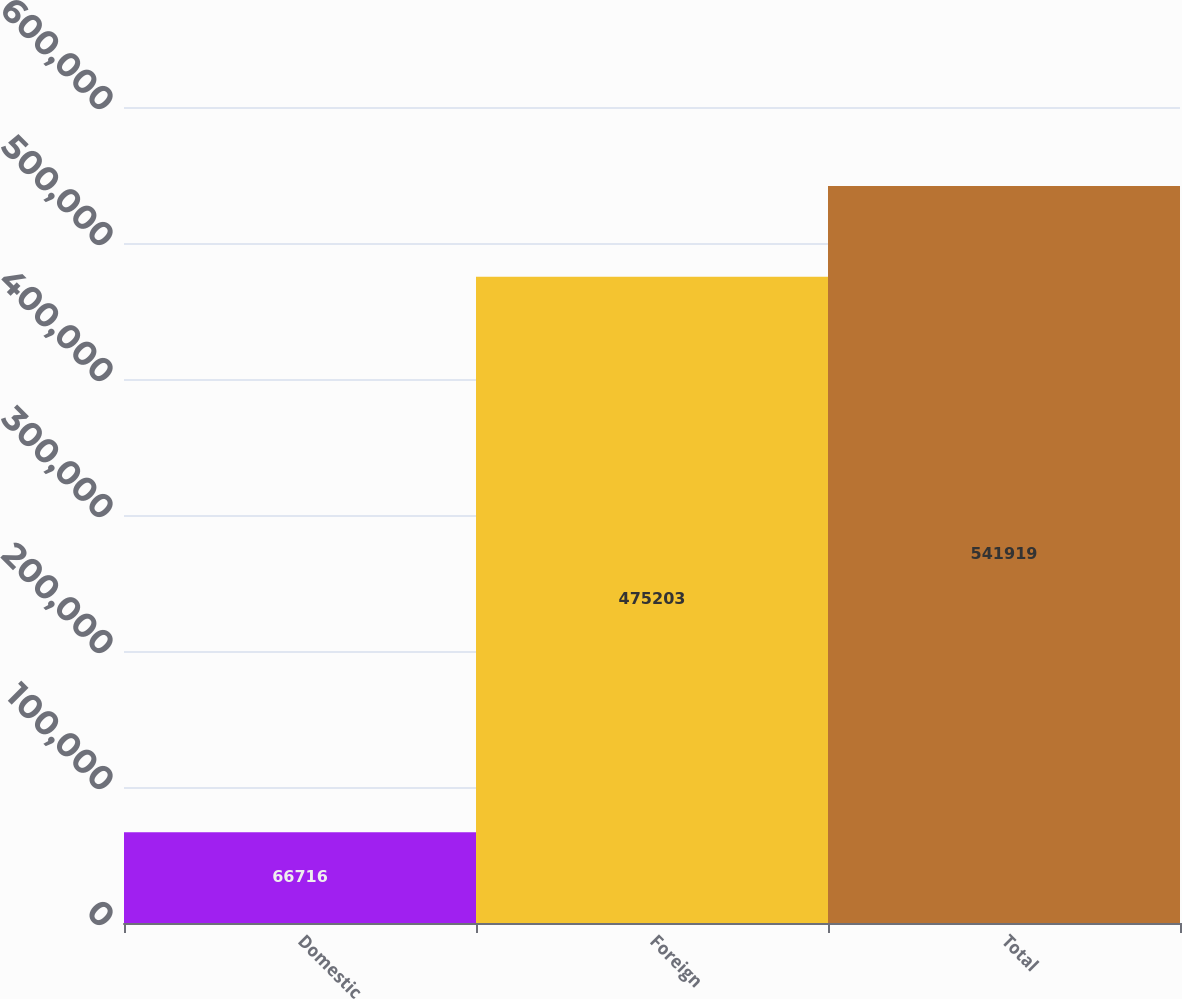<chart> <loc_0><loc_0><loc_500><loc_500><bar_chart><fcel>Domestic<fcel>Foreign<fcel>Total<nl><fcel>66716<fcel>475203<fcel>541919<nl></chart> 